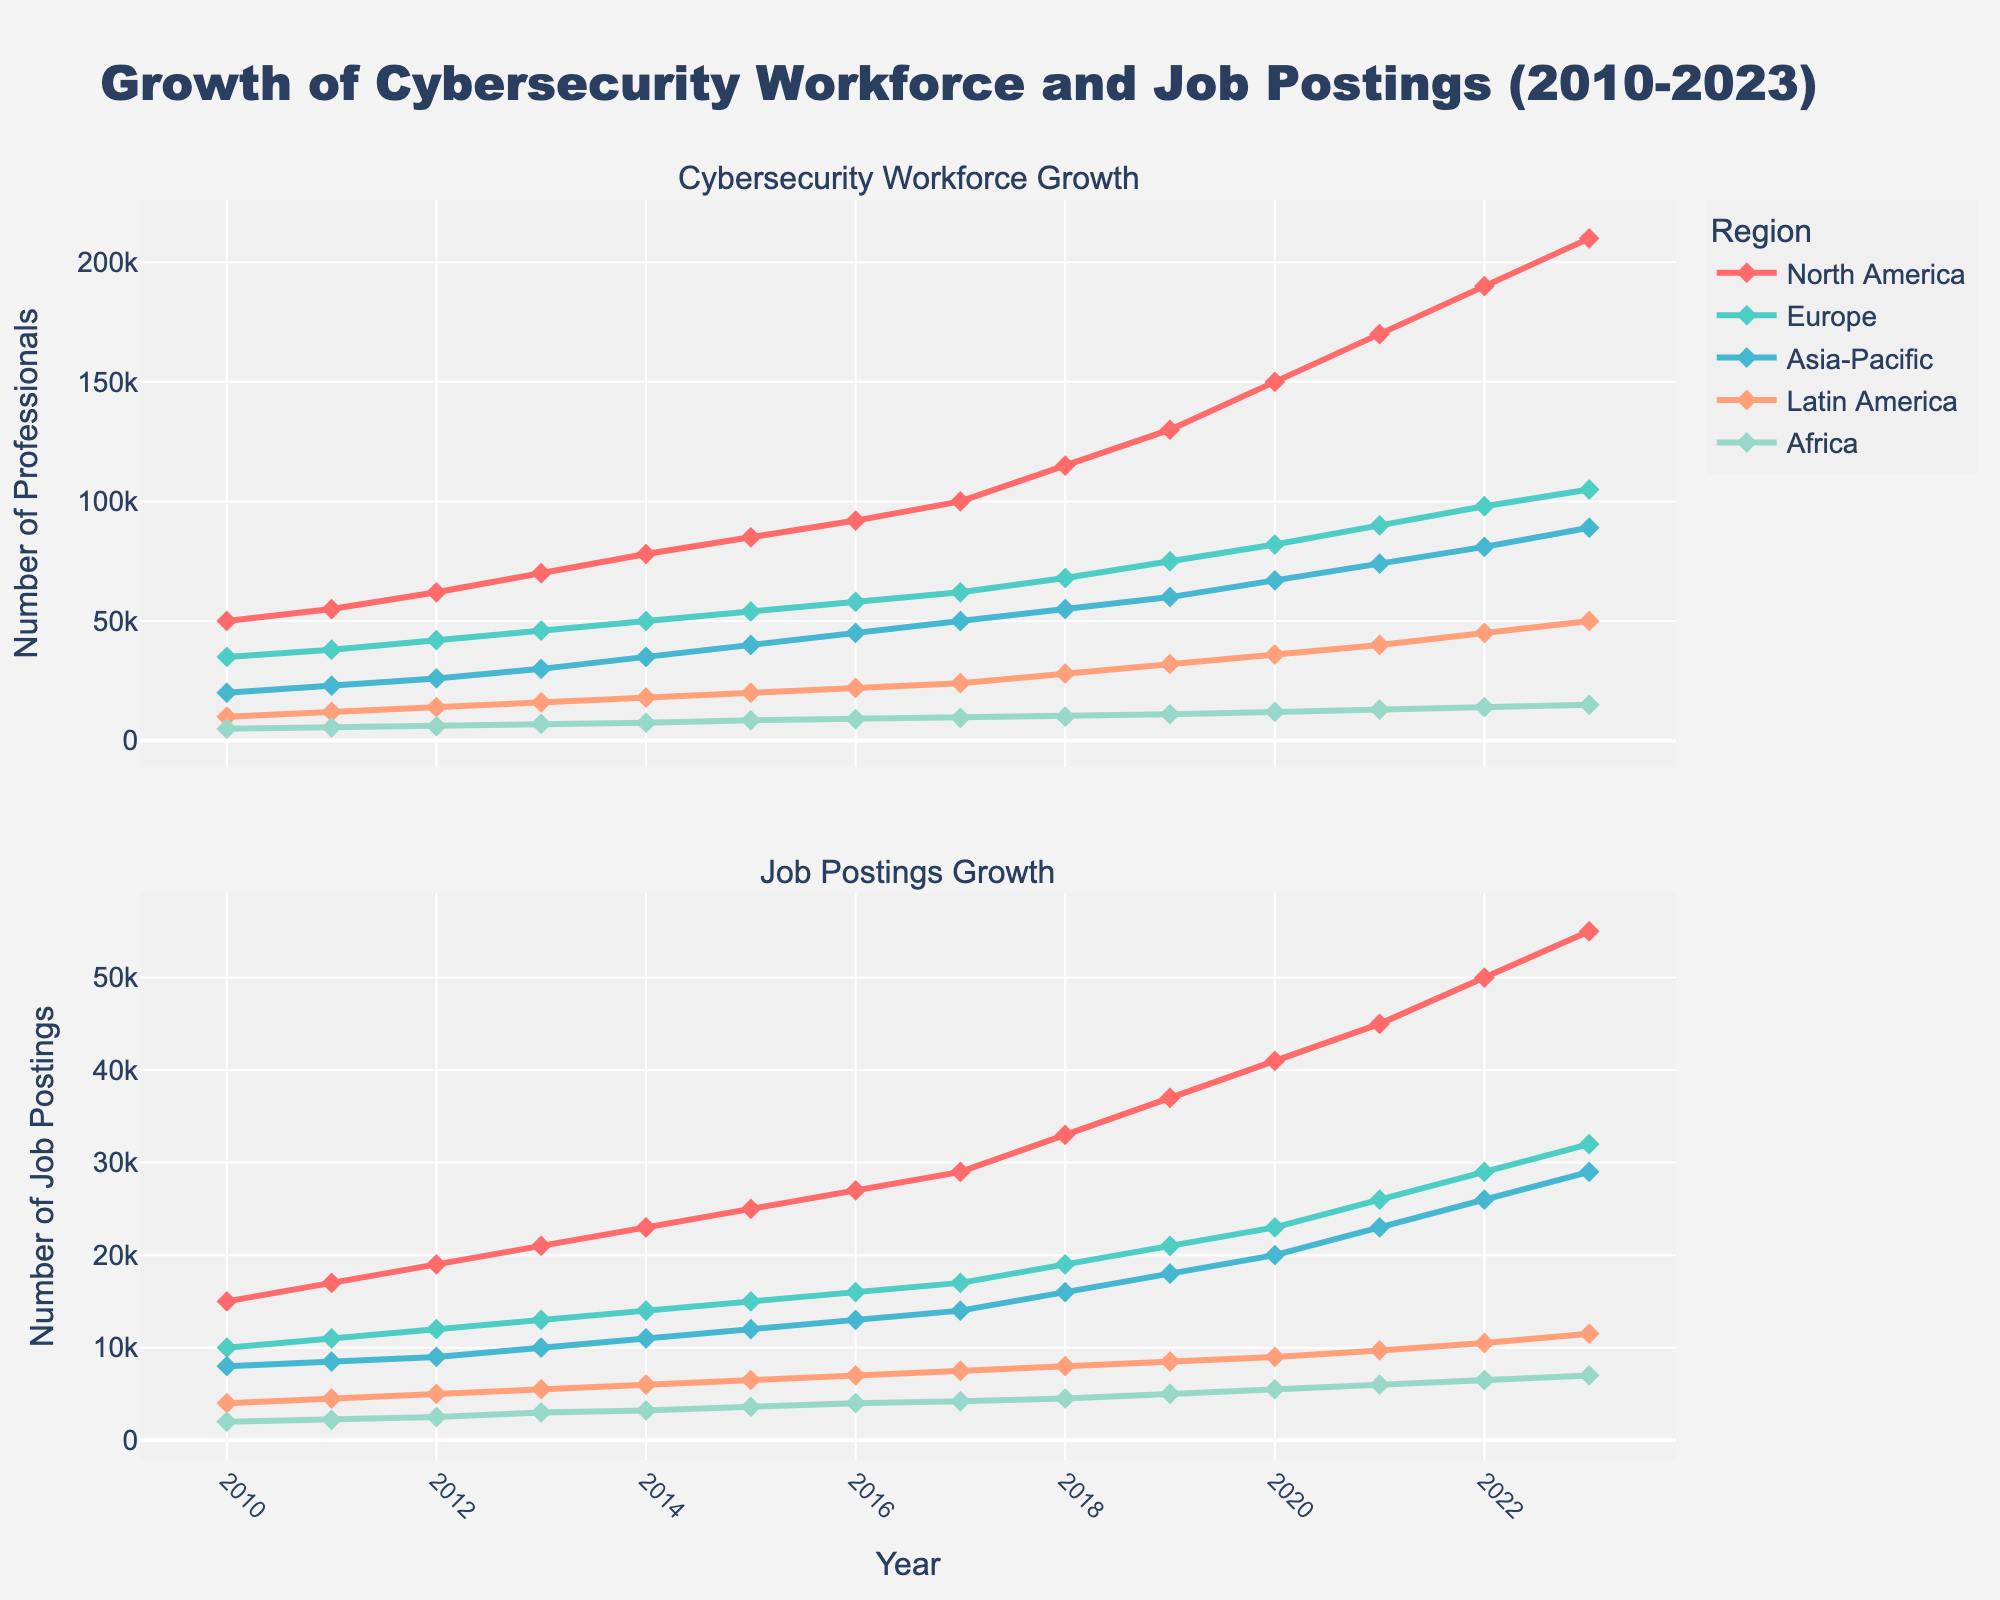How many regions are displayed in the figure? There are different colored lines representing various regions. By counting the distinct lines, we can determine the number of regions displayed.
Answer: 5 What is the title of the figure? The title is usually positioned at the top center of the figure. It provides an overview of the contents.
Answer: Growth of Cybersecurity Workforce and Job Postings (2010-2023) In which year did North America cross 100,000 cybersecurity professionals? Locate the North America line in the "Cybersecurity Workforce Growth" subplot and follow it until it crosses the 100,000 mark on the y-axis. Note the corresponding year on the x-axis.
Answer: 2017 How does the cybersecurity workforce growth in Europe compare to Asia-Pacific in 2023? Identify the lines for Europe and Asia-Pacific in the "Cybersecurity Workforce Growth" subplot and compare their values at the year 2023.
Answer: Europe has more cybersecurity professionals than Asia-Pacific Which year experienced the highest job postings growth in Latin America? Examine the "Job Postings Growth" subplot and identify the peak point of the Latin America line. This corresponds to the year with the highest job postings.
Answer: 2023 What is the overall trend of cybersecurity workforce growth in Africa from 2010 to 2023? Follow the Africa line in the "Cybersecurity Workforce Growth" subplot from 2010 to 2023. Describe the direction and changes in the line's trajectory.
Answer: Increasing How many cybersecurity job postings were there in Europe in 2020? Locate the Europe line in the "Job Postings Growth" subplot for the year 2020. Read the corresponding value on the y-axis.
Answer: 23,000 Compare the job postings growth in North America and Latin America in 2015. Which region had more job postings? Identify the job postings data for North America and Latin America in the "Job Postings Growth" subplot for the year 2015. Compare the values.
Answer: North America What is the average number of cybersecurity professionals in Asia-Pacific over the period from 2010 to 2023? Sum the cybersecurity workforce numbers for Asia-Pacific from 2010 to 2023 and divide by the number of years (14) to find the average.
Answer: 49,286 What was the increase in the cybersecurity workforce for North America from 2010 to 2023? Subtract the number of cybersecurity professionals in 2010 from the number in 2023 for North America.
Answer: 160,000 